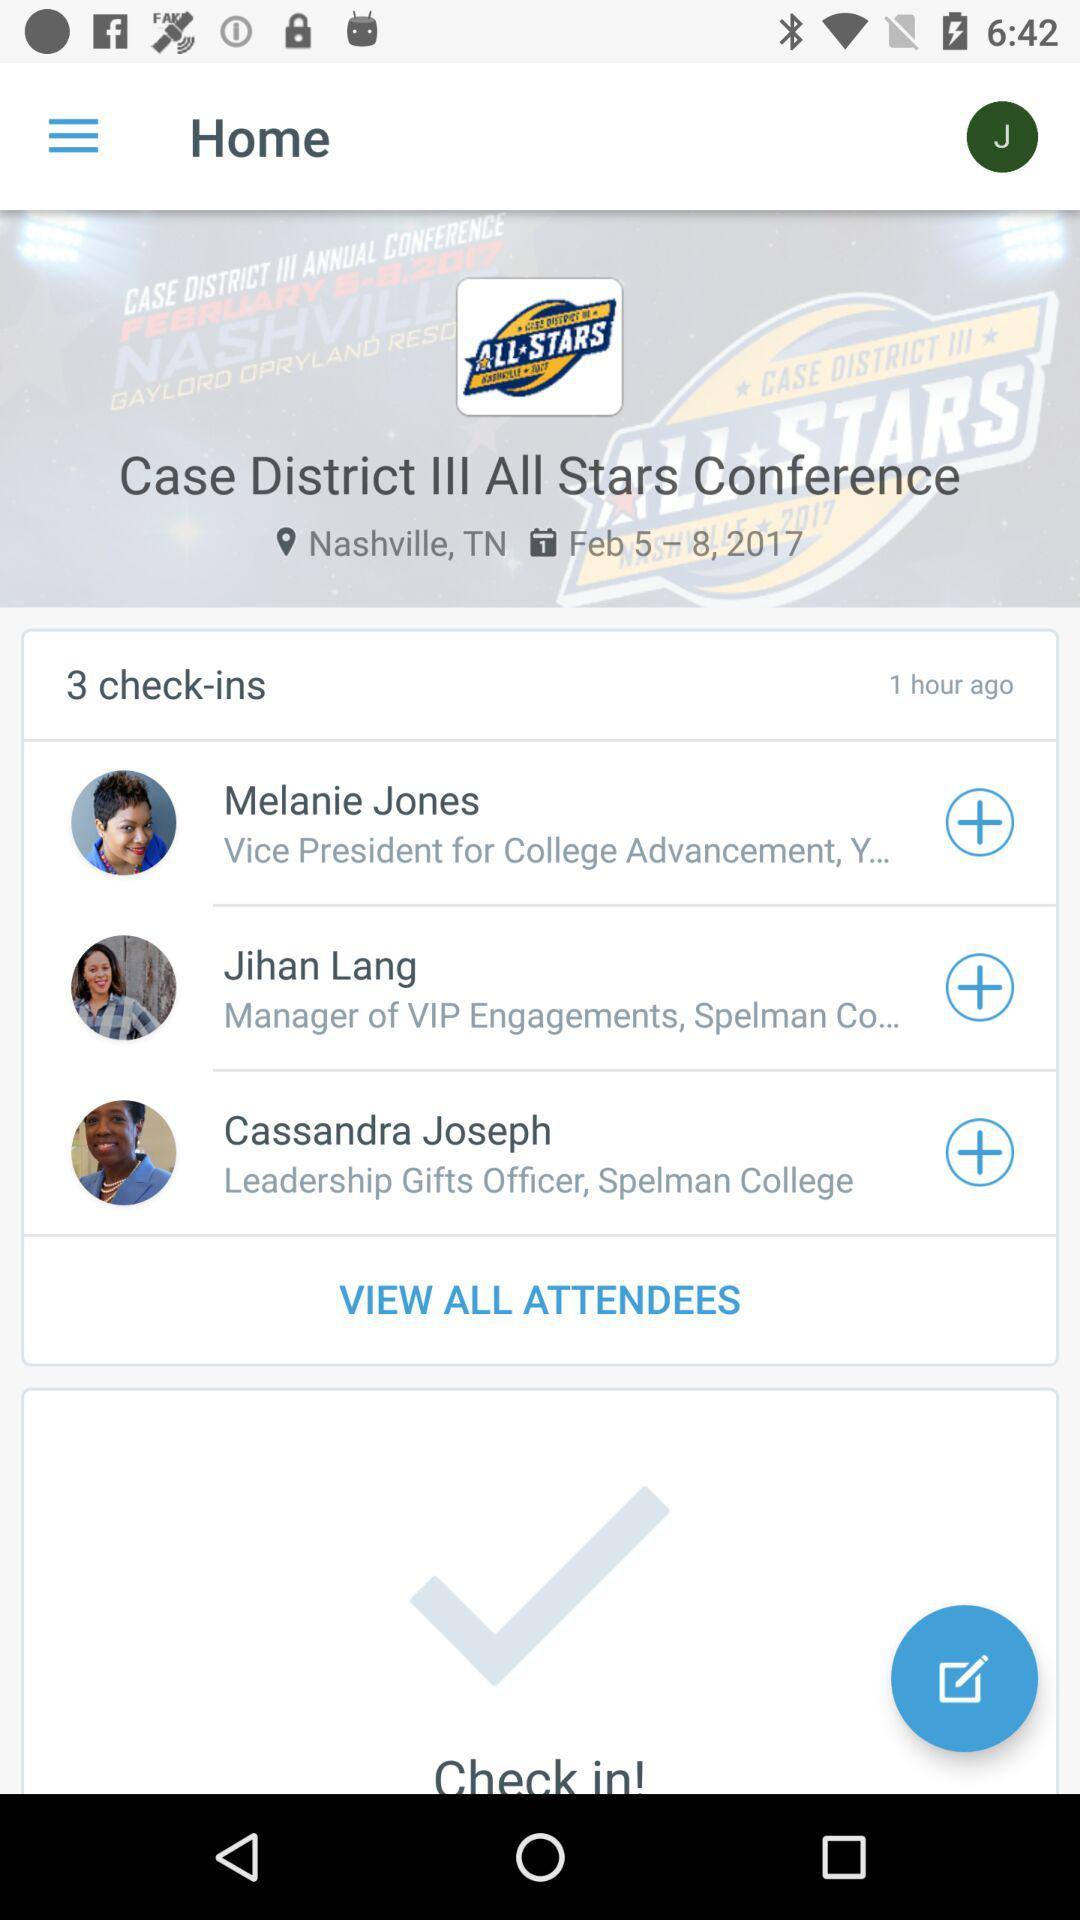How many check-ins are there?
Answer the question using a single word or phrase. 3 